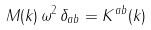Convert formula to latex. <formula><loc_0><loc_0><loc_500><loc_500>M ( { k } ) \, \omega ^ { 2 } \, \delta _ { a b } = K ^ { a b } ( { k } )</formula> 